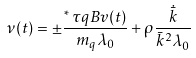Convert formula to latex. <formula><loc_0><loc_0><loc_500><loc_500>\nu ( t ) = \pm \frac { ^ { \ast } \, \tau q B v ( t ) } { m _ { q } \lambda _ { 0 } } + \rho \frac { \dot { \bar { k } } } { \bar { k } ^ { 2 } \lambda _ { 0 } }</formula> 